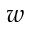Convert formula to latex. <formula><loc_0><loc_0><loc_500><loc_500>w</formula> 